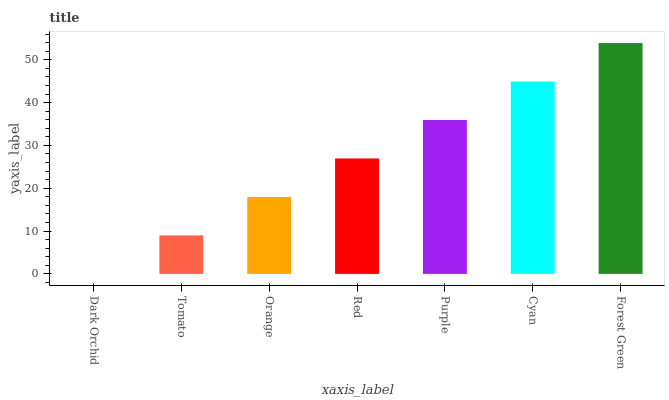Is Dark Orchid the minimum?
Answer yes or no. Yes. Is Forest Green the maximum?
Answer yes or no. Yes. Is Tomato the minimum?
Answer yes or no. No. Is Tomato the maximum?
Answer yes or no. No. Is Tomato greater than Dark Orchid?
Answer yes or no. Yes. Is Dark Orchid less than Tomato?
Answer yes or no. Yes. Is Dark Orchid greater than Tomato?
Answer yes or no. No. Is Tomato less than Dark Orchid?
Answer yes or no. No. Is Red the high median?
Answer yes or no. Yes. Is Red the low median?
Answer yes or no. Yes. Is Tomato the high median?
Answer yes or no. No. Is Orange the low median?
Answer yes or no. No. 